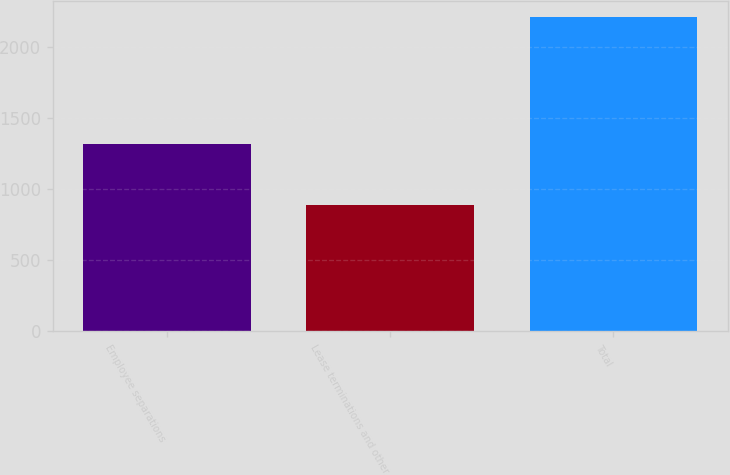Convert chart to OTSL. <chart><loc_0><loc_0><loc_500><loc_500><bar_chart><fcel>Employee separations<fcel>Lease terminations and other<fcel>Total<nl><fcel>1319<fcel>890<fcel>2209<nl></chart> 